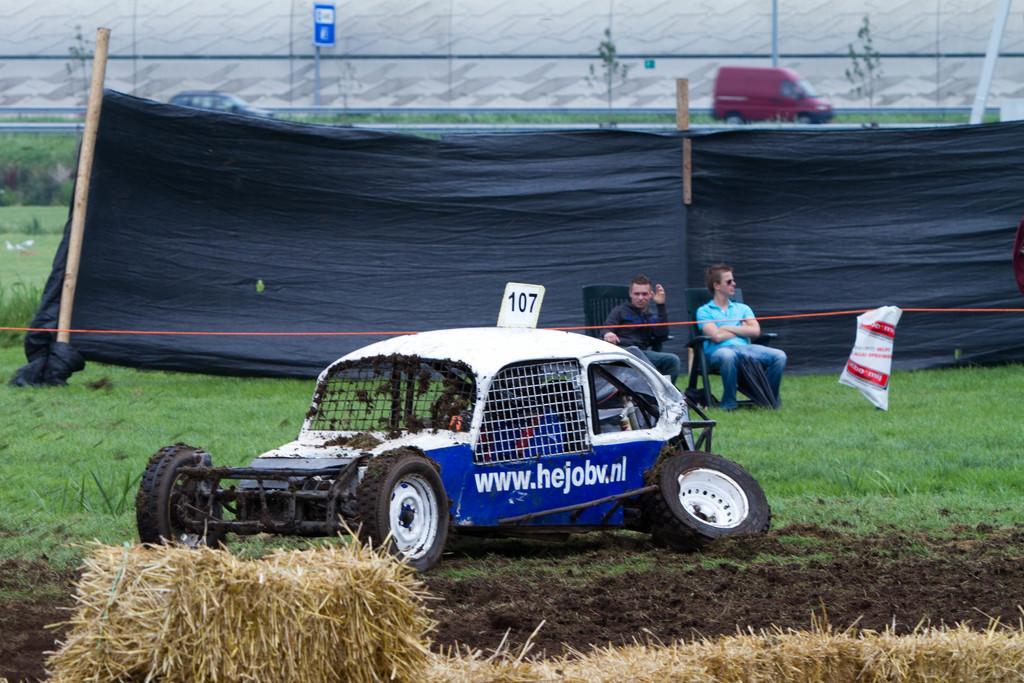In one or two sentences, can you explain what this image depicts? In this image we can see two people sitting in chairs. At the bottom we can see the hay. And we can see the tent and some boards. We can see the vehicles on the road. 